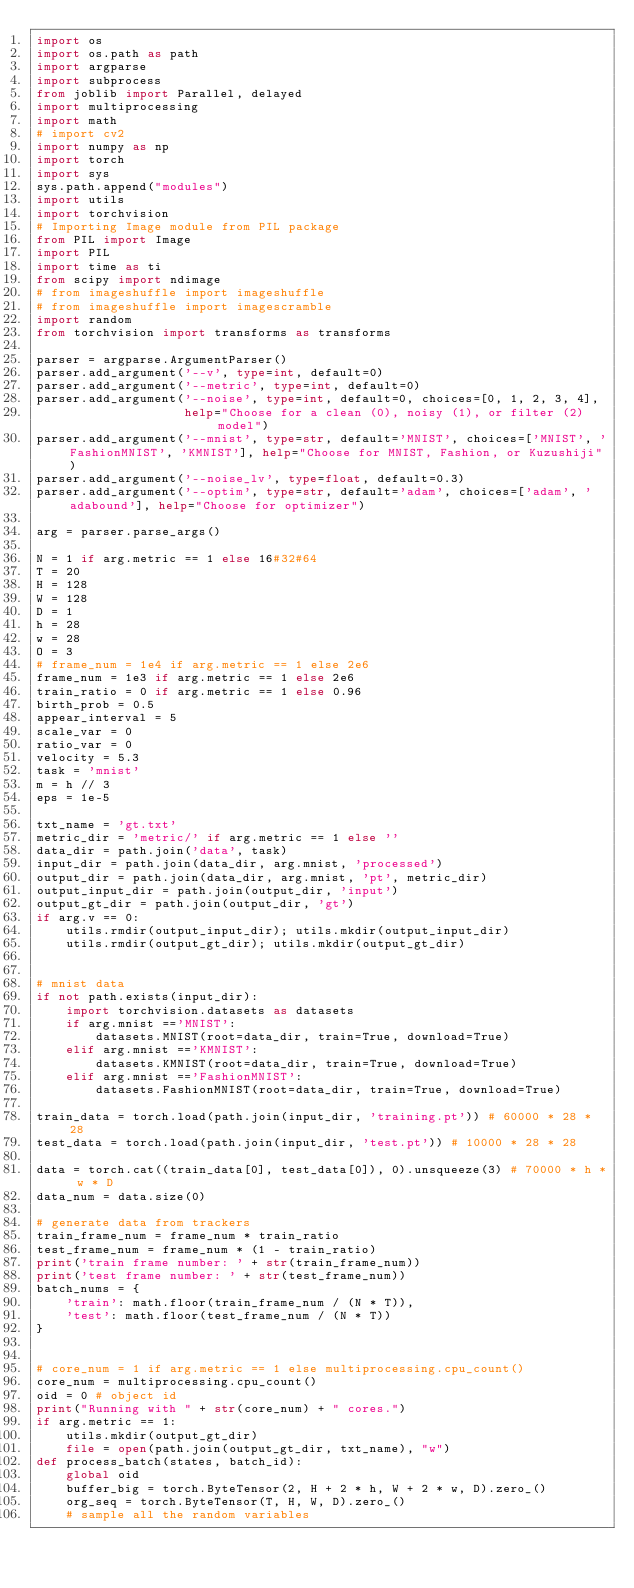Convert code to text. <code><loc_0><loc_0><loc_500><loc_500><_Python_>import os
import os.path as path
import argparse
import subprocess
from joblib import Parallel, delayed
import multiprocessing
import math
# import cv2
import numpy as np
import torch
import sys
sys.path.append("modules")
import utils
import torchvision
# Importing Image module from PIL package  
from PIL import Image  
import PIL  
import time as ti
from scipy import ndimage
# from imageshuffle import imageshuffle
# from imageshuffle import imagescramble
import random
from torchvision import transforms as transforms

parser = argparse.ArgumentParser()
parser.add_argument('--v', type=int, default=0)
parser.add_argument('--metric', type=int, default=0)
parser.add_argument('--noise', type=int, default=0, choices=[0, 1, 2, 3, 4],
                    help="Choose for a clean (0), noisy (1), or filter (2) model")
parser.add_argument('--mnist', type=str, default='MNIST', choices=['MNIST', 'FashionMNIST', 'KMNIST'], help="Choose for MNIST, Fashion, or Kuzushiji")
parser.add_argument('--noise_lv', type=float, default=0.3)
parser.add_argument('--optim', type=str, default='adam', choices=['adam', 'adabound'], help="Choose for optimizer")

arg = parser.parse_args()

N = 1 if arg.metric == 1 else 16#32#64
T = 20
H = 128
W = 128
D = 1
h = 28
w = 28
O = 3
# frame_num = 1e4 if arg.metric == 1 else 2e6
frame_num = 1e3 if arg.metric == 1 else 2e6
train_ratio = 0 if arg.metric == 1 else 0.96
birth_prob = 0.5
appear_interval = 5
scale_var = 0
ratio_var = 0
velocity = 5.3
task = 'mnist'
m = h // 3
eps = 1e-5

txt_name = 'gt.txt'
metric_dir = 'metric/' if arg.metric == 1 else ''
data_dir = path.join('data', task)
input_dir = path.join(data_dir, arg.mnist, 'processed')
output_dir = path.join(data_dir, arg.mnist, 'pt', metric_dir)
output_input_dir = path.join(output_dir, 'input')
output_gt_dir = path.join(output_dir, 'gt')
if arg.v == 0:
    utils.rmdir(output_input_dir); utils.mkdir(output_input_dir)
    utils.rmdir(output_gt_dir); utils.mkdir(output_gt_dir)


# mnist data
if not path.exists(input_dir):
    import torchvision.datasets as datasets
    if arg.mnist =='MNIST':
        datasets.MNIST(root=data_dir, train=True, download=True)
    elif arg.mnist =='KMNIST':
        datasets.KMNIST(root=data_dir, train=True, download=True)
    elif arg.mnist =='FashionMNIST':
        datasets.FashionMNIST(root=data_dir, train=True, download=True)

train_data = torch.load(path.join(input_dir, 'training.pt')) # 60000 * 28 * 28
test_data = torch.load(path.join(input_dir, 'test.pt')) # 10000 * 28 * 28

data = torch.cat((train_data[0], test_data[0]), 0).unsqueeze(3) # 70000 * h * w * D
data_num = data.size(0)

# generate data from trackers
train_frame_num = frame_num * train_ratio
test_frame_num = frame_num * (1 - train_ratio)
print('train frame number: ' + str(train_frame_num))
print('test frame number: ' + str(test_frame_num))
batch_nums = {
    'train': math.floor(train_frame_num / (N * T)),
    'test': math.floor(test_frame_num / (N * T))
}


# core_num = 1 if arg.metric == 1 else multiprocessing.cpu_count()
core_num = multiprocessing.cpu_count()
oid = 0 # object id
print("Running with " + str(core_num) + " cores.")
if arg.metric == 1:
    utils.mkdir(output_gt_dir)
    file = open(path.join(output_gt_dir, txt_name), "w")
def process_batch(states, batch_id):
    global oid
    buffer_big = torch.ByteTensor(2, H + 2 * h, W + 2 * w, D).zero_()
    org_seq = torch.ByteTensor(T, H, W, D).zero_()
    # sample all the random variables</code> 